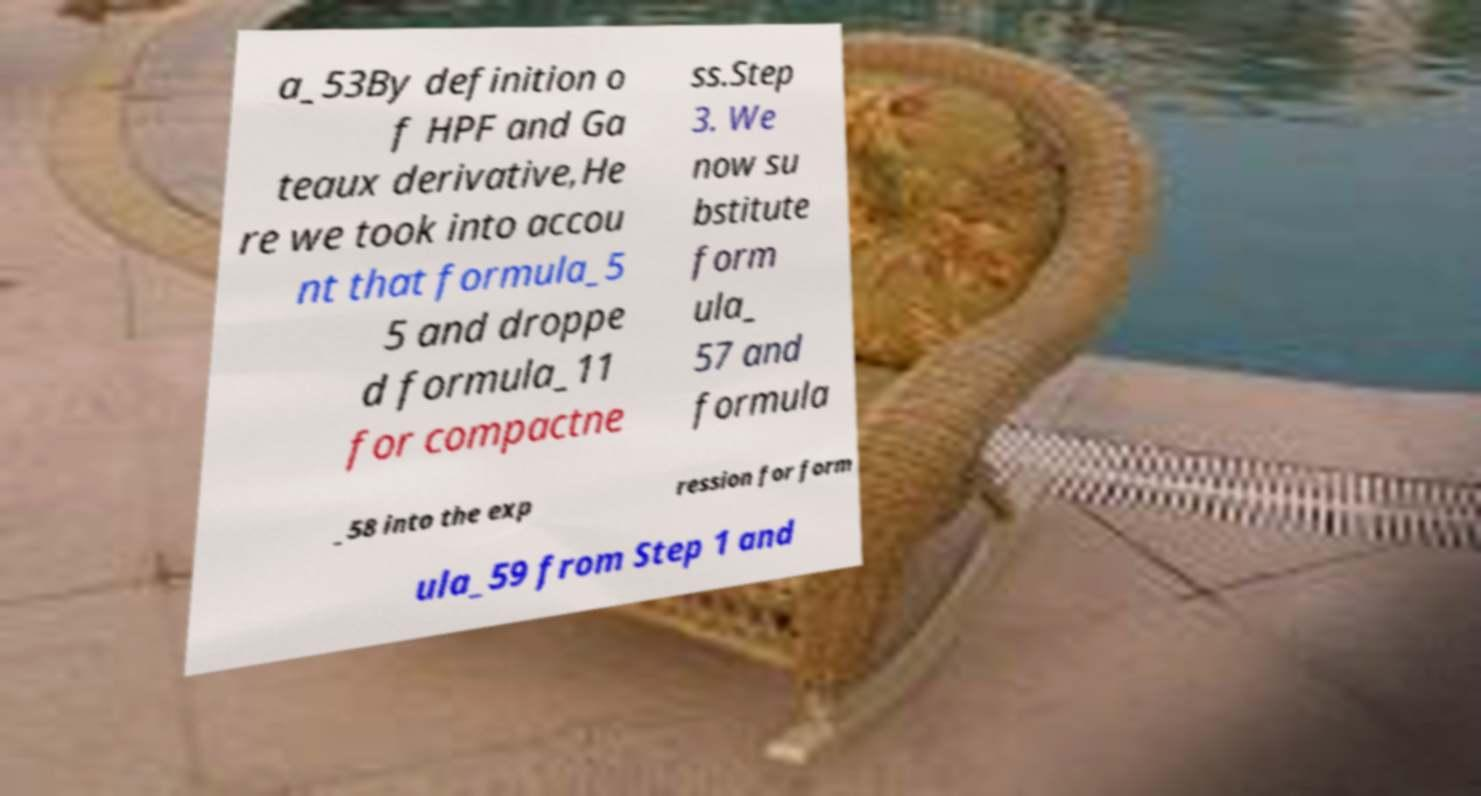For documentation purposes, I need the text within this image transcribed. Could you provide that? a_53By definition o f HPF and Ga teaux derivative,He re we took into accou nt that formula_5 5 and droppe d formula_11 for compactne ss.Step 3. We now su bstitute form ula_ 57 and formula _58 into the exp ression for form ula_59 from Step 1 and 